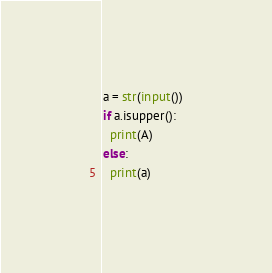Convert code to text. <code><loc_0><loc_0><loc_500><loc_500><_Python_>a = str(input())
if a.isupper():
  print(A)
else:
  print(a)</code> 